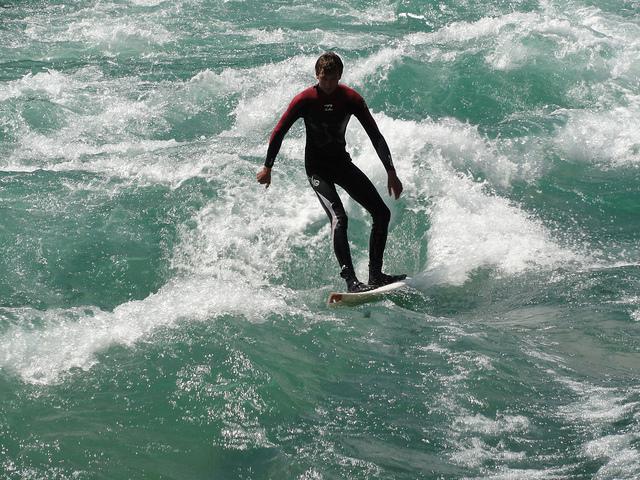What color is the mens wetsuit?
Quick response, please. Black. Is this person wearing shoes?
Concise answer only. No. Is he swimming?
Short answer required. No. Does the man have shorts on?
Quick response, please. No. What is on the man's head?
Be succinct. Nothing. What color wave is the man riding his board on?
Be succinct. Blue. How can he stand that far forward?
Answer briefly. Balance. 